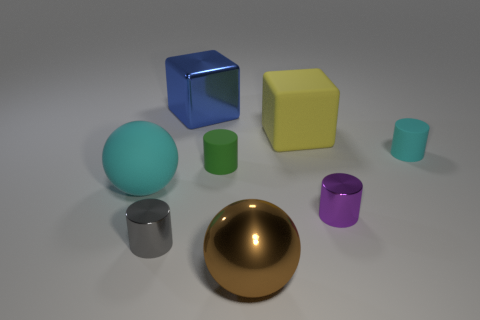Can you tell me what shapes are present and which is the most abundant? In the image, there are cubes, spheres, cylinders, and a hemisphere. The most abundant shape is the cylinder, with three instances. 